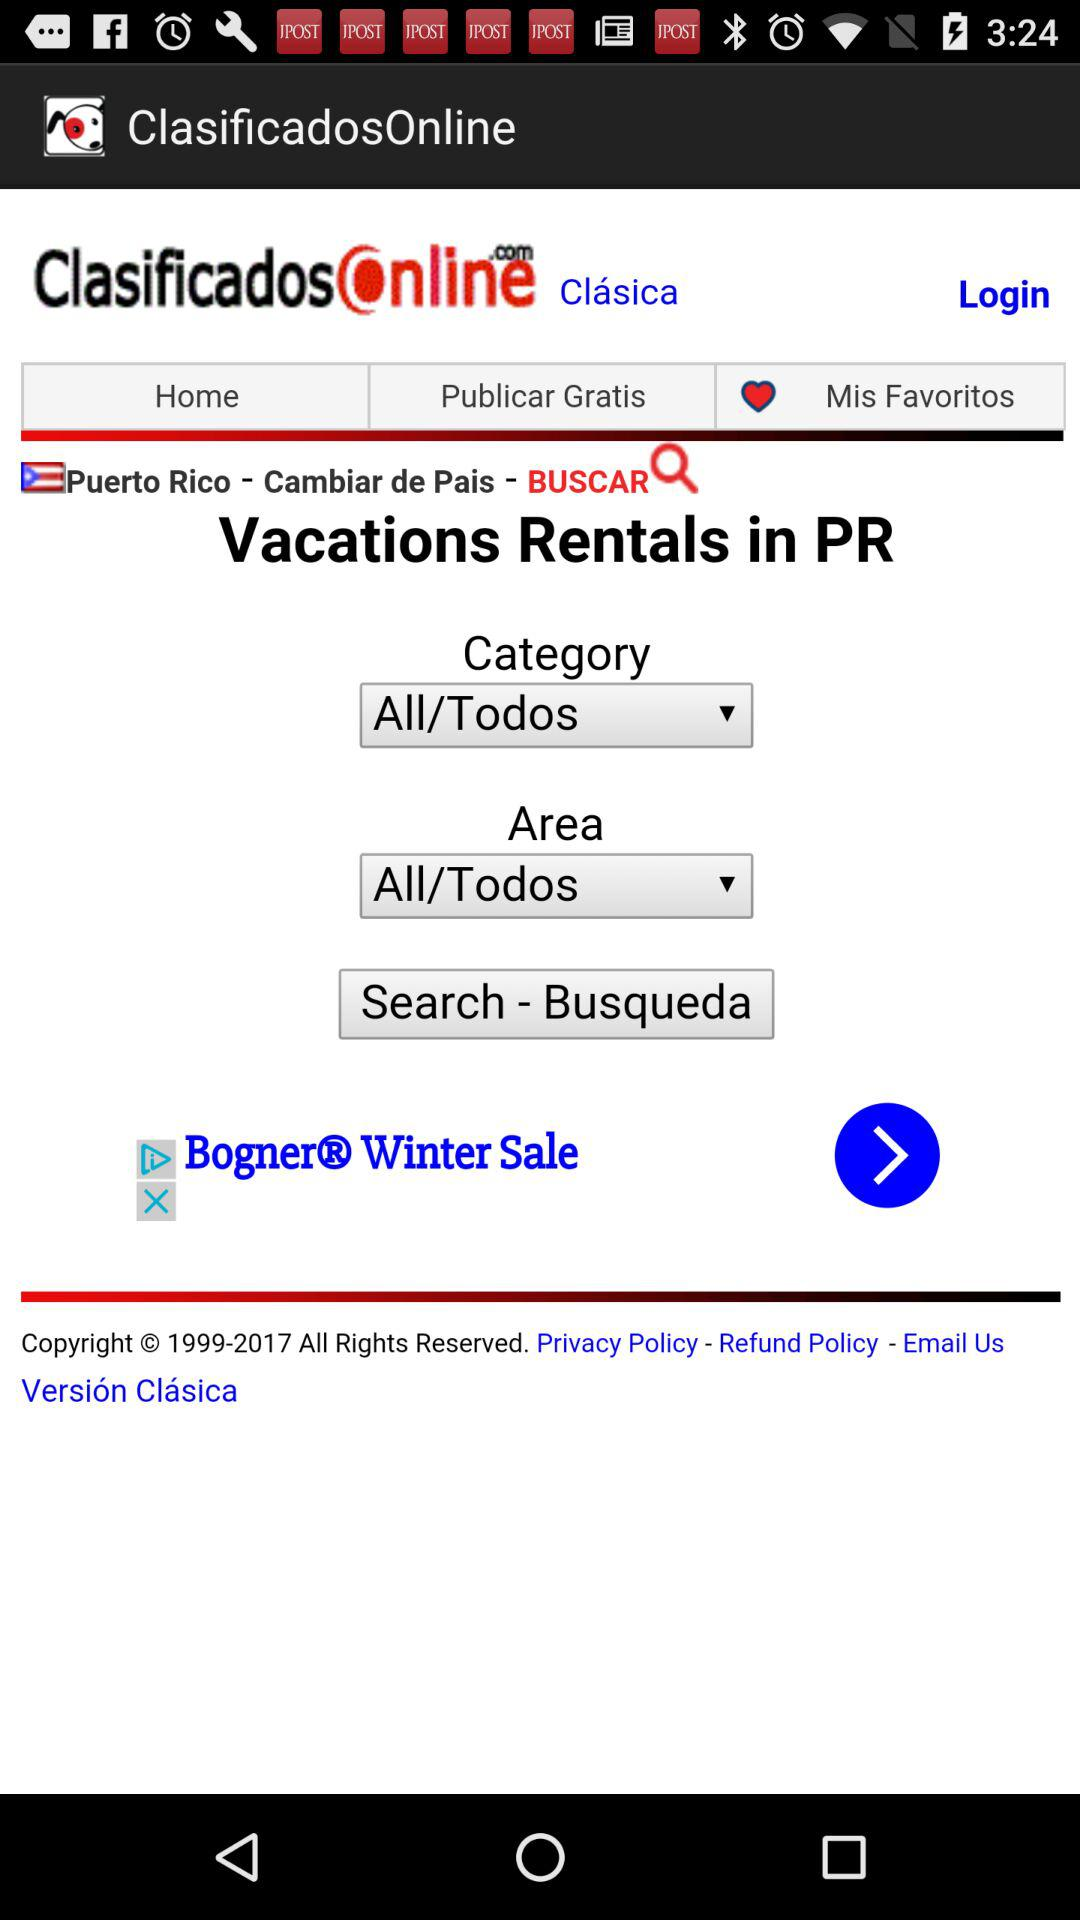Which option has been selected in "Area"? The selected option is "All/Todos". 